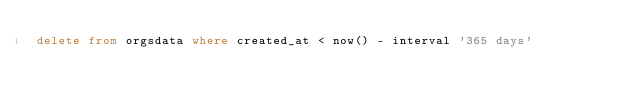Convert code to text. <code><loc_0><loc_0><loc_500><loc_500><_SQL_>delete from orgsdata where created_at < now() - interval '365 days'</code> 